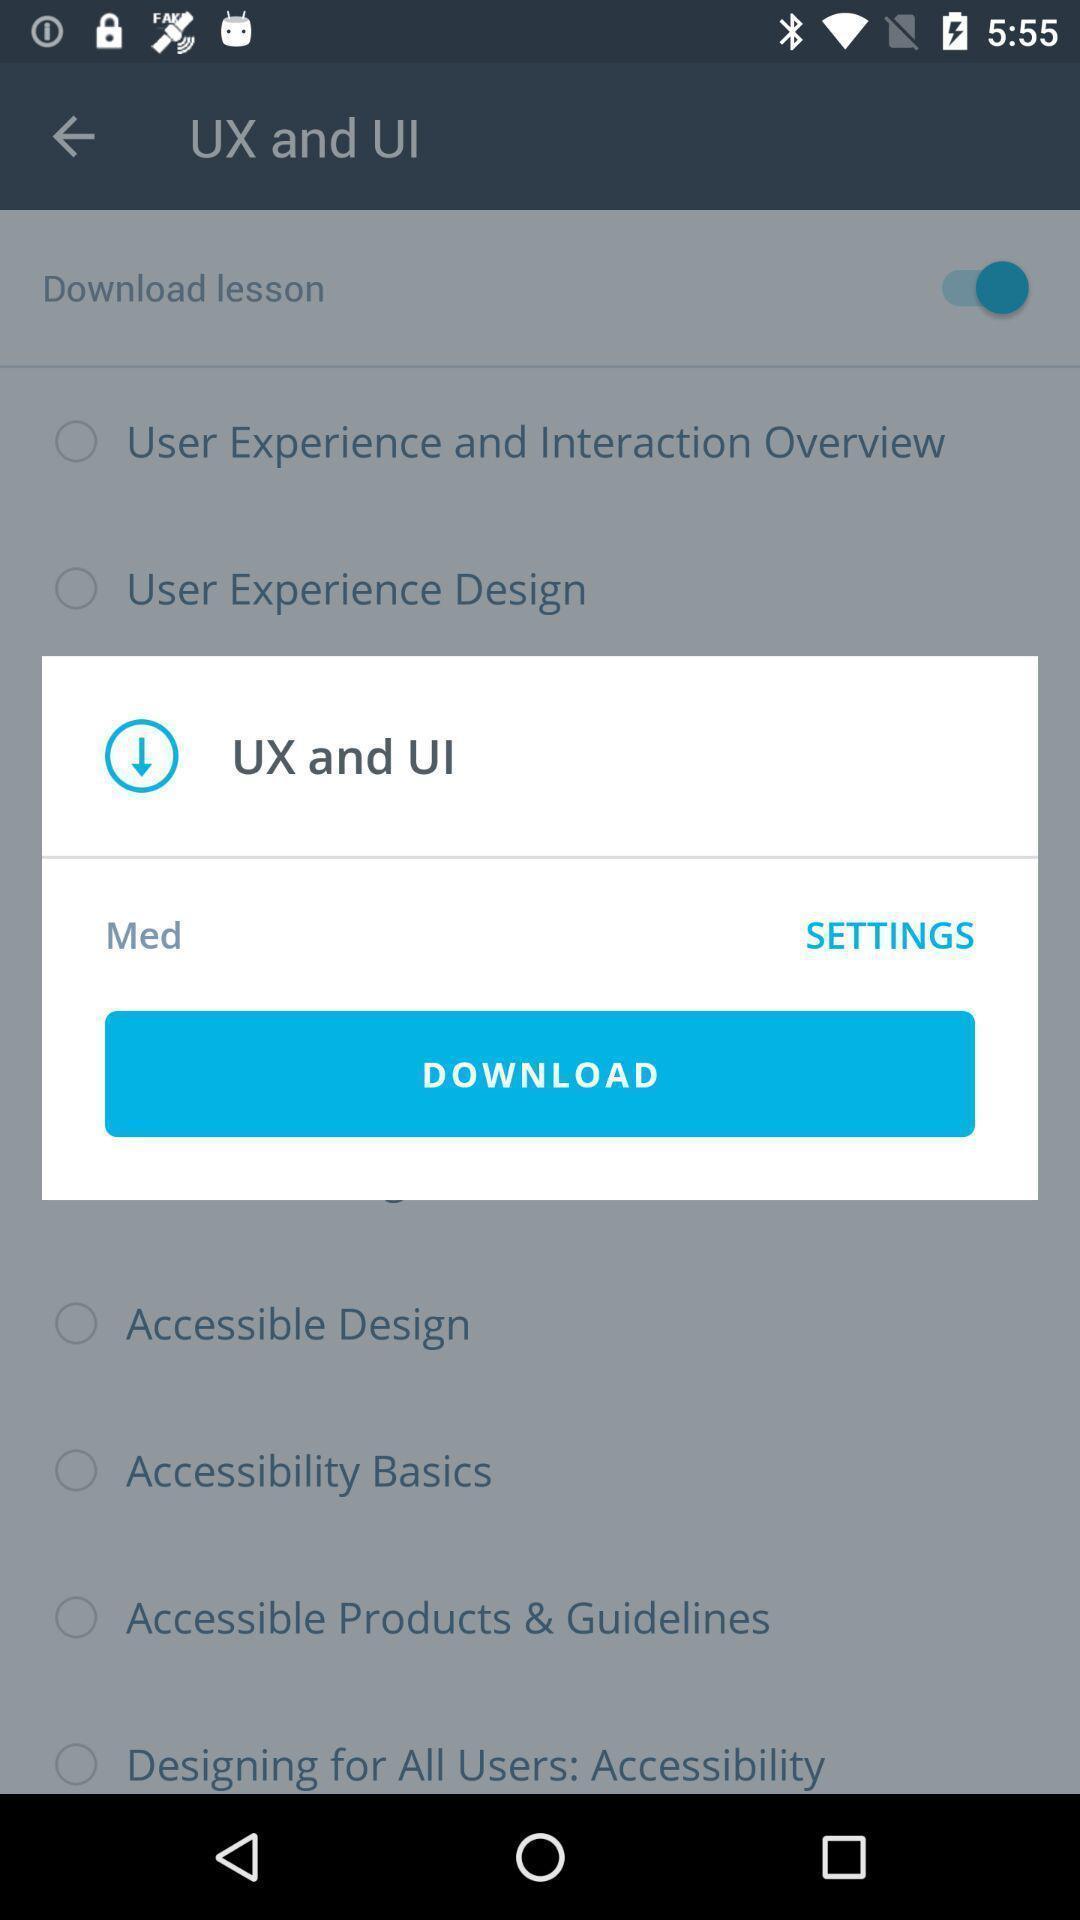Describe the content in this image. Popup page for downloading of a lesson. 